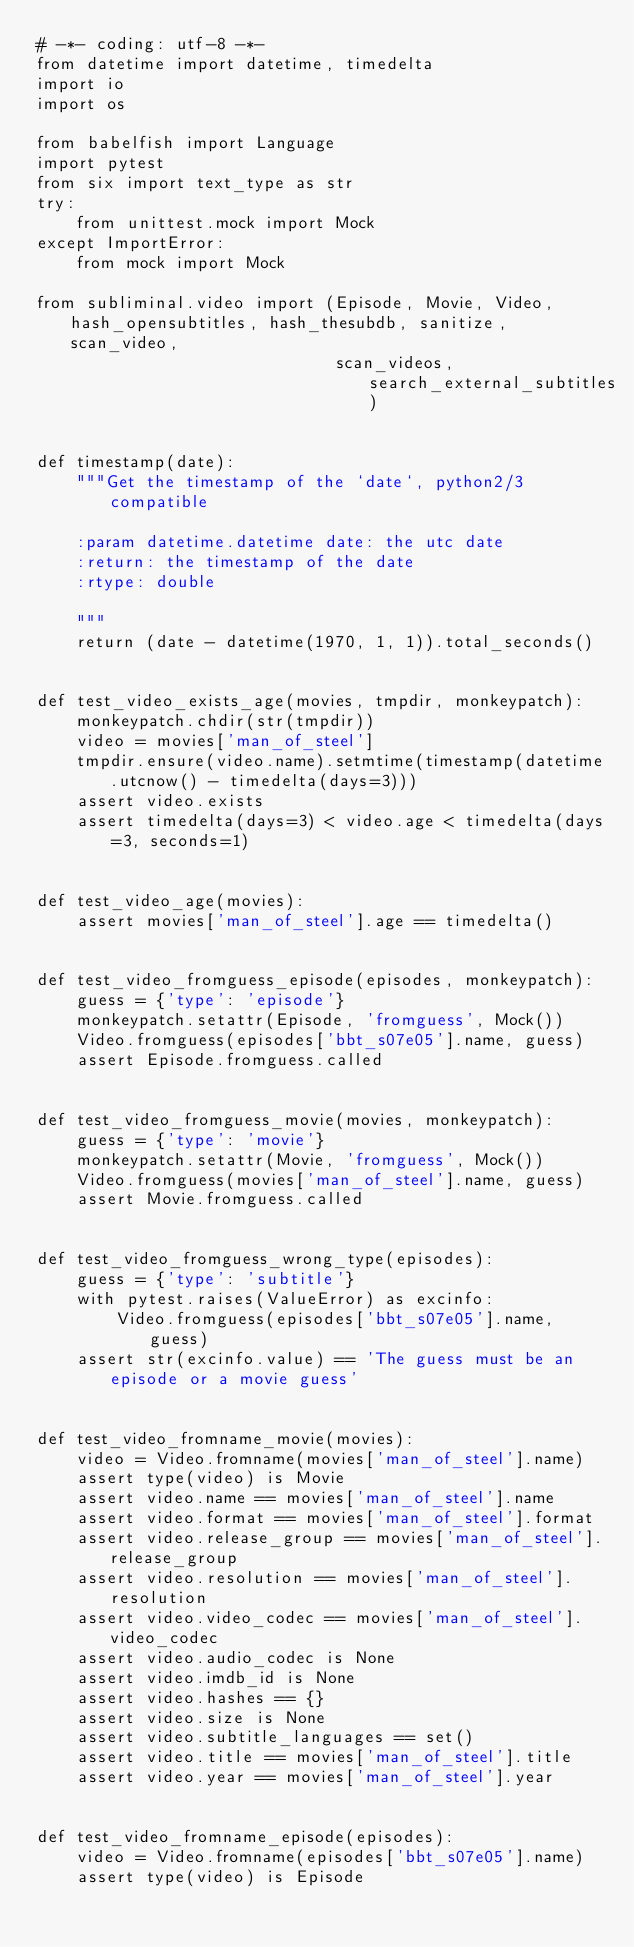Convert code to text. <code><loc_0><loc_0><loc_500><loc_500><_Python_># -*- coding: utf-8 -*-
from datetime import datetime, timedelta
import io
import os

from babelfish import Language
import pytest
from six import text_type as str
try:
    from unittest.mock import Mock
except ImportError:
    from mock import Mock

from subliminal.video import (Episode, Movie, Video, hash_opensubtitles, hash_thesubdb, sanitize, scan_video,
                              scan_videos, search_external_subtitles)


def timestamp(date):
    """Get the timestamp of the `date`, python2/3 compatible

    :param datetime.datetime date: the utc date
    :return: the timestamp of the date
    :rtype: double

    """
    return (date - datetime(1970, 1, 1)).total_seconds()


def test_video_exists_age(movies, tmpdir, monkeypatch):
    monkeypatch.chdir(str(tmpdir))
    video = movies['man_of_steel']
    tmpdir.ensure(video.name).setmtime(timestamp(datetime.utcnow() - timedelta(days=3)))
    assert video.exists
    assert timedelta(days=3) < video.age < timedelta(days=3, seconds=1)


def test_video_age(movies):
    assert movies['man_of_steel'].age == timedelta()


def test_video_fromguess_episode(episodes, monkeypatch):
    guess = {'type': 'episode'}
    monkeypatch.setattr(Episode, 'fromguess', Mock())
    Video.fromguess(episodes['bbt_s07e05'].name, guess)
    assert Episode.fromguess.called


def test_video_fromguess_movie(movies, monkeypatch):
    guess = {'type': 'movie'}
    monkeypatch.setattr(Movie, 'fromguess', Mock())
    Video.fromguess(movies['man_of_steel'].name, guess)
    assert Movie.fromguess.called


def test_video_fromguess_wrong_type(episodes):
    guess = {'type': 'subtitle'}
    with pytest.raises(ValueError) as excinfo:
        Video.fromguess(episodes['bbt_s07e05'].name, guess)
    assert str(excinfo.value) == 'The guess must be an episode or a movie guess'


def test_video_fromname_movie(movies):
    video = Video.fromname(movies['man_of_steel'].name)
    assert type(video) is Movie
    assert video.name == movies['man_of_steel'].name
    assert video.format == movies['man_of_steel'].format
    assert video.release_group == movies['man_of_steel'].release_group
    assert video.resolution == movies['man_of_steel'].resolution
    assert video.video_codec == movies['man_of_steel'].video_codec
    assert video.audio_codec is None
    assert video.imdb_id is None
    assert video.hashes == {}
    assert video.size is None
    assert video.subtitle_languages == set()
    assert video.title == movies['man_of_steel'].title
    assert video.year == movies['man_of_steel'].year


def test_video_fromname_episode(episodes):
    video = Video.fromname(episodes['bbt_s07e05'].name)
    assert type(video) is Episode</code> 